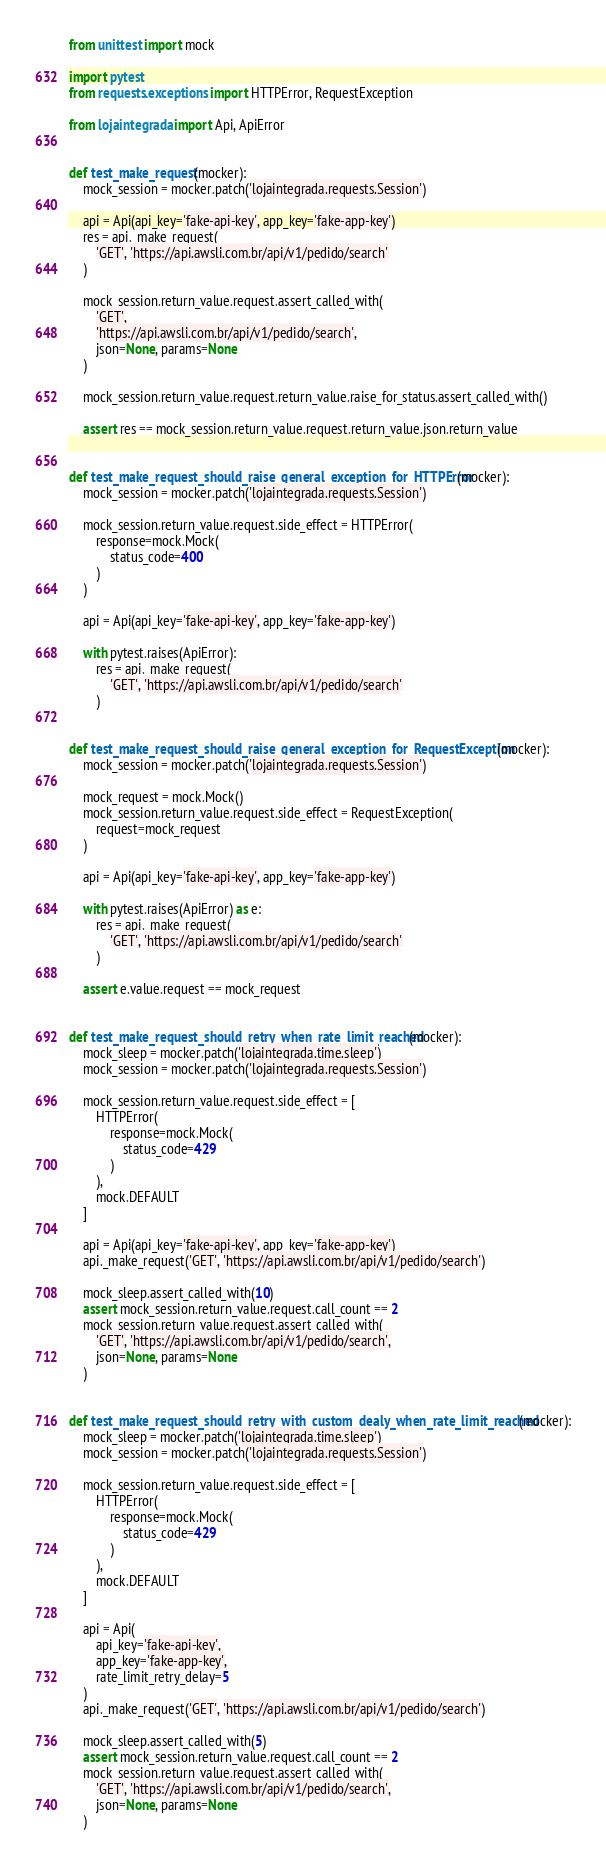Convert code to text. <code><loc_0><loc_0><loc_500><loc_500><_Python_>from unittest import mock

import pytest
from requests.exceptions import HTTPError, RequestException

from lojaintegrada import Api, ApiError


def test_make_request(mocker):
    mock_session = mocker.patch('lojaintegrada.requests.Session')

    api = Api(api_key='fake-api-key', app_key='fake-app-key')
    res = api._make_request(
        'GET', 'https://api.awsli.com.br/api/v1/pedido/search'
    )

    mock_session.return_value.request.assert_called_with(
        'GET',
        'https://api.awsli.com.br/api/v1/pedido/search',
        json=None, params=None
    )

    mock_session.return_value.request.return_value.raise_for_status.assert_called_with()

    assert res == mock_session.return_value.request.return_value.json.return_value


def test_make_request_should_raise_general_exception_for_HTTPError(mocker):
    mock_session = mocker.patch('lojaintegrada.requests.Session')

    mock_session.return_value.request.side_effect = HTTPError(
        response=mock.Mock(
            status_code=400
        )
    )

    api = Api(api_key='fake-api-key', app_key='fake-app-key')

    with pytest.raises(ApiError):
        res = api._make_request(
            'GET', 'https://api.awsli.com.br/api/v1/pedido/search'
        )


def test_make_request_should_raise_general_exception_for_RequestException(mocker):
    mock_session = mocker.patch('lojaintegrada.requests.Session')

    mock_request = mock.Mock()
    mock_session.return_value.request.side_effect = RequestException(
        request=mock_request
    )

    api = Api(api_key='fake-api-key', app_key='fake-app-key')

    with pytest.raises(ApiError) as e:
        res = api._make_request(
            'GET', 'https://api.awsli.com.br/api/v1/pedido/search'
        )

    assert e.value.request == mock_request


def test_make_request_should_retry_when_rate_limit_reached(mocker):
    mock_sleep = mocker.patch('lojaintegrada.time.sleep')
    mock_session = mocker.patch('lojaintegrada.requests.Session')

    mock_session.return_value.request.side_effect = [
        HTTPError(
            response=mock.Mock(
                status_code=429
            )
        ),
        mock.DEFAULT
    ]

    api = Api(api_key='fake-api-key', app_key='fake-app-key')
    api._make_request('GET', 'https://api.awsli.com.br/api/v1/pedido/search')

    mock_sleep.assert_called_with(10)
    assert mock_session.return_value.request.call_count == 2
    mock_session.return_value.request.assert_called_with(
        'GET', 'https://api.awsli.com.br/api/v1/pedido/search',
        json=None, params=None
    )


def test_make_request_should_retry_with_custom_dealy_when_rate_limit_reached(mocker):
    mock_sleep = mocker.patch('lojaintegrada.time.sleep')
    mock_session = mocker.patch('lojaintegrada.requests.Session')

    mock_session.return_value.request.side_effect = [
        HTTPError(
            response=mock.Mock(
                status_code=429
            )
        ),
        mock.DEFAULT
    ]

    api = Api(
        api_key='fake-api-key',
        app_key='fake-app-key',
        rate_limit_retry_delay=5
    )
    api._make_request('GET', 'https://api.awsli.com.br/api/v1/pedido/search')

    mock_sleep.assert_called_with(5)
    assert mock_session.return_value.request.call_count == 2
    mock_session.return_value.request.assert_called_with(
        'GET', 'https://api.awsli.com.br/api/v1/pedido/search',
        json=None, params=None
    )
</code> 